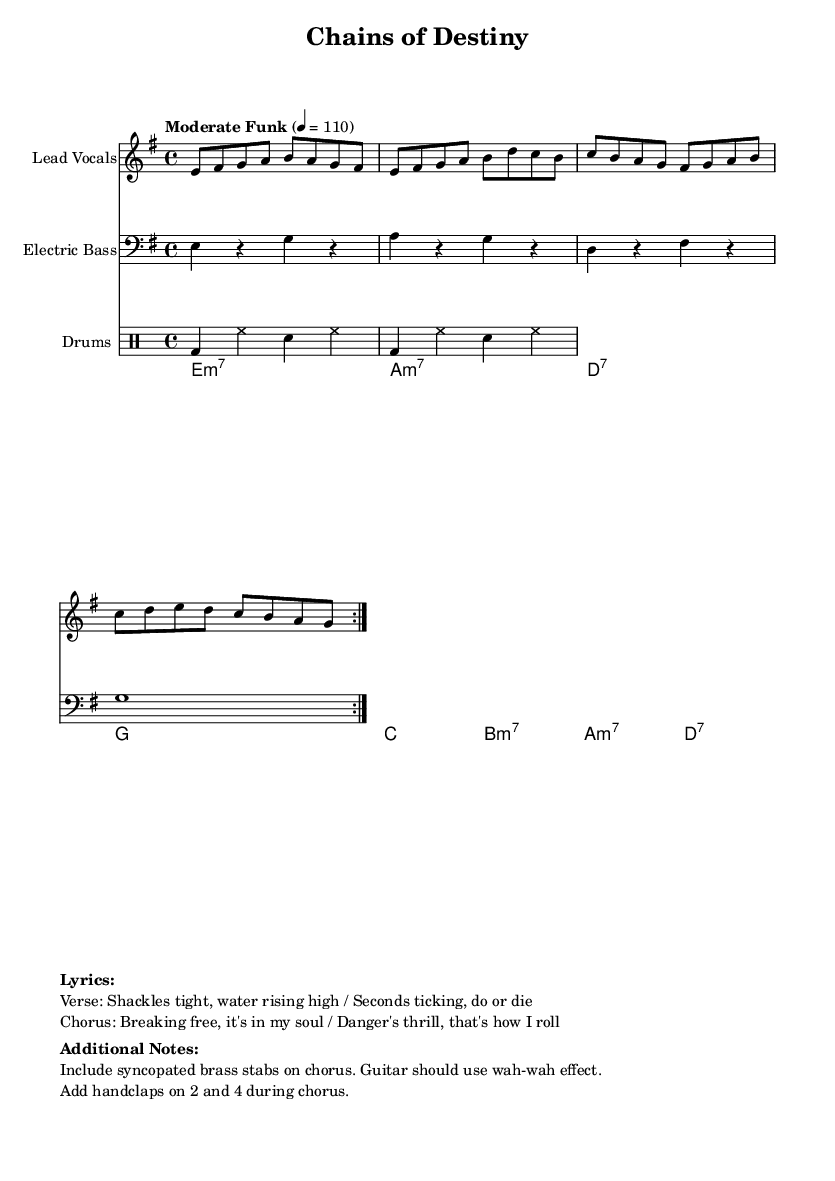What is the key signature of this music? The key signature is E minor, which has one sharp (F#) that indicates the pitches in the scale used throughout the piece.
Answer: E minor What is the time signature of the piece? The time signature is 4/4, indicated at the beginning of the music, meaning there are four beats in each measure and the quarter note receives one beat.
Answer: 4/4 What is the tempo marking for the song? The tempo marking is "Moderate Funk," indicating a pace of 110 beats per minute, which is specified in the global context of the score.
Answer: Moderate Funk How many times is the verse repeated? The verse is repeated twice, as indicated by the repeat markings (volta) before entering the chorus section which follows after each verse.
Answer: 2 What is the lyrical theme highlighted in the song? The lyrics focus on themes of danger and freedom, particularly illustrated through phrases that evoke urgent imagery of escape and the thrill associated with it.
Answer: Danger and freedom What instruments are included in this arrangement? There are lead vocals, electric bass, and drums; these are all specified in the new staff headings and their respective parts within the score.
Answer: Lead vocals, electric bass, drums What additional musical elements are suggested for the chorus? The chorus suggests syncopated brass stabs, a wah-wah effect on guitar, and handclaps on beats 2 and 4, enhancing the funk style and overall energy of the performance.
Answer: Syncopated brass stabs, wah-wah effect, handclaps 